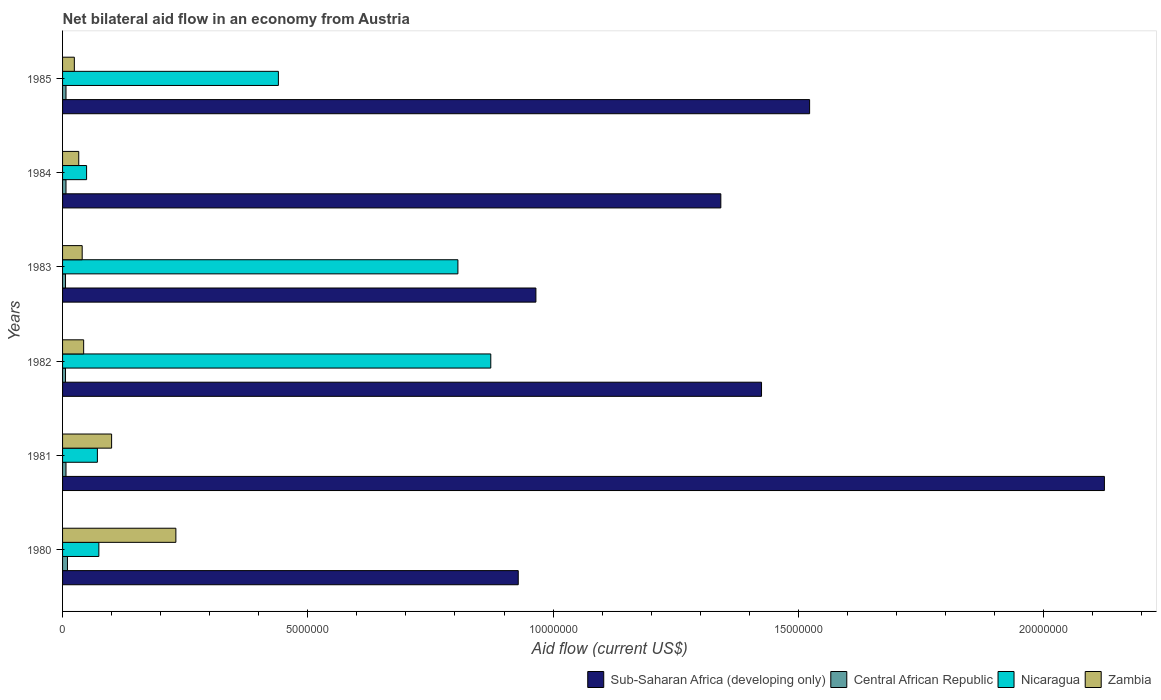How many groups of bars are there?
Provide a short and direct response. 6. Are the number of bars per tick equal to the number of legend labels?
Your response must be concise. Yes. Are the number of bars on each tick of the Y-axis equal?
Your answer should be very brief. Yes. How many bars are there on the 2nd tick from the bottom?
Provide a short and direct response. 4. What is the label of the 5th group of bars from the top?
Offer a very short reply. 1981. What is the net bilateral aid flow in Zambia in 1983?
Offer a terse response. 4.00e+05. Across all years, what is the maximum net bilateral aid flow in Nicaragua?
Ensure brevity in your answer.  8.73e+06. Across all years, what is the minimum net bilateral aid flow in Sub-Saharan Africa (developing only)?
Your answer should be very brief. 9.29e+06. In which year was the net bilateral aid flow in Sub-Saharan Africa (developing only) maximum?
Keep it short and to the point. 1981. In which year was the net bilateral aid flow in Central African Republic minimum?
Your response must be concise. 1982. What is the total net bilateral aid flow in Sub-Saharan Africa (developing only) in the graph?
Your response must be concise. 8.31e+07. What is the difference between the net bilateral aid flow in Nicaragua in 1980 and that in 1985?
Your answer should be very brief. -3.66e+06. What is the average net bilateral aid flow in Nicaragua per year?
Give a very brief answer. 3.86e+06. In the year 1981, what is the difference between the net bilateral aid flow in Zambia and net bilateral aid flow in Sub-Saharan Africa (developing only)?
Ensure brevity in your answer.  -2.02e+07. What is the ratio of the net bilateral aid flow in Sub-Saharan Africa (developing only) in 1980 to that in 1983?
Ensure brevity in your answer.  0.96. Is the difference between the net bilateral aid flow in Zambia in 1981 and 1985 greater than the difference between the net bilateral aid flow in Sub-Saharan Africa (developing only) in 1981 and 1985?
Provide a succinct answer. No. What is the difference between the highest and the second highest net bilateral aid flow in Zambia?
Provide a succinct answer. 1.31e+06. What is the difference between the highest and the lowest net bilateral aid flow in Nicaragua?
Keep it short and to the point. 8.24e+06. In how many years, is the net bilateral aid flow in Sub-Saharan Africa (developing only) greater than the average net bilateral aid flow in Sub-Saharan Africa (developing only) taken over all years?
Offer a very short reply. 3. Is the sum of the net bilateral aid flow in Sub-Saharan Africa (developing only) in 1981 and 1984 greater than the maximum net bilateral aid flow in Central African Republic across all years?
Your response must be concise. Yes. Is it the case that in every year, the sum of the net bilateral aid flow in Zambia and net bilateral aid flow in Nicaragua is greater than the sum of net bilateral aid flow in Sub-Saharan Africa (developing only) and net bilateral aid flow in Central African Republic?
Offer a terse response. No. What does the 4th bar from the top in 1983 represents?
Offer a terse response. Sub-Saharan Africa (developing only). What does the 2nd bar from the bottom in 1980 represents?
Keep it short and to the point. Central African Republic. Are all the bars in the graph horizontal?
Your answer should be compact. Yes. How many years are there in the graph?
Your answer should be compact. 6. Does the graph contain any zero values?
Your answer should be compact. No. Does the graph contain grids?
Offer a terse response. No. How many legend labels are there?
Your answer should be very brief. 4. How are the legend labels stacked?
Give a very brief answer. Horizontal. What is the title of the graph?
Provide a short and direct response. Net bilateral aid flow in an economy from Austria. Does "Equatorial Guinea" appear as one of the legend labels in the graph?
Your response must be concise. No. What is the label or title of the X-axis?
Your answer should be very brief. Aid flow (current US$). What is the Aid flow (current US$) in Sub-Saharan Africa (developing only) in 1980?
Give a very brief answer. 9.29e+06. What is the Aid flow (current US$) of Nicaragua in 1980?
Ensure brevity in your answer.  7.40e+05. What is the Aid flow (current US$) in Zambia in 1980?
Offer a very short reply. 2.31e+06. What is the Aid flow (current US$) of Sub-Saharan Africa (developing only) in 1981?
Your answer should be compact. 2.12e+07. What is the Aid flow (current US$) in Central African Republic in 1981?
Make the answer very short. 7.00e+04. What is the Aid flow (current US$) in Nicaragua in 1981?
Offer a very short reply. 7.10e+05. What is the Aid flow (current US$) in Sub-Saharan Africa (developing only) in 1982?
Provide a succinct answer. 1.42e+07. What is the Aid flow (current US$) of Central African Republic in 1982?
Provide a succinct answer. 6.00e+04. What is the Aid flow (current US$) of Nicaragua in 1982?
Keep it short and to the point. 8.73e+06. What is the Aid flow (current US$) in Zambia in 1982?
Ensure brevity in your answer.  4.30e+05. What is the Aid flow (current US$) of Sub-Saharan Africa (developing only) in 1983?
Provide a succinct answer. 9.65e+06. What is the Aid flow (current US$) of Central African Republic in 1983?
Your response must be concise. 6.00e+04. What is the Aid flow (current US$) in Nicaragua in 1983?
Offer a terse response. 8.06e+06. What is the Aid flow (current US$) in Zambia in 1983?
Give a very brief answer. 4.00e+05. What is the Aid flow (current US$) of Sub-Saharan Africa (developing only) in 1984?
Keep it short and to the point. 1.34e+07. What is the Aid flow (current US$) in Central African Republic in 1984?
Provide a succinct answer. 7.00e+04. What is the Aid flow (current US$) in Nicaragua in 1984?
Offer a very short reply. 4.90e+05. What is the Aid flow (current US$) of Zambia in 1984?
Provide a succinct answer. 3.30e+05. What is the Aid flow (current US$) in Sub-Saharan Africa (developing only) in 1985?
Your response must be concise. 1.52e+07. What is the Aid flow (current US$) of Nicaragua in 1985?
Provide a succinct answer. 4.40e+06. What is the Aid flow (current US$) of Zambia in 1985?
Give a very brief answer. 2.40e+05. Across all years, what is the maximum Aid flow (current US$) in Sub-Saharan Africa (developing only)?
Provide a short and direct response. 2.12e+07. Across all years, what is the maximum Aid flow (current US$) of Central African Republic?
Offer a terse response. 1.00e+05. Across all years, what is the maximum Aid flow (current US$) of Nicaragua?
Your answer should be very brief. 8.73e+06. Across all years, what is the maximum Aid flow (current US$) in Zambia?
Your answer should be very brief. 2.31e+06. Across all years, what is the minimum Aid flow (current US$) in Sub-Saharan Africa (developing only)?
Provide a succinct answer. 9.29e+06. Across all years, what is the minimum Aid flow (current US$) of Zambia?
Your answer should be very brief. 2.40e+05. What is the total Aid flow (current US$) of Sub-Saharan Africa (developing only) in the graph?
Your response must be concise. 8.31e+07. What is the total Aid flow (current US$) in Nicaragua in the graph?
Provide a short and direct response. 2.31e+07. What is the total Aid flow (current US$) in Zambia in the graph?
Make the answer very short. 4.71e+06. What is the difference between the Aid flow (current US$) in Sub-Saharan Africa (developing only) in 1980 and that in 1981?
Keep it short and to the point. -1.20e+07. What is the difference between the Aid flow (current US$) of Central African Republic in 1980 and that in 1981?
Offer a very short reply. 3.00e+04. What is the difference between the Aid flow (current US$) of Zambia in 1980 and that in 1981?
Offer a very short reply. 1.31e+06. What is the difference between the Aid flow (current US$) of Sub-Saharan Africa (developing only) in 1980 and that in 1982?
Offer a terse response. -4.96e+06. What is the difference between the Aid flow (current US$) of Central African Republic in 1980 and that in 1982?
Ensure brevity in your answer.  4.00e+04. What is the difference between the Aid flow (current US$) of Nicaragua in 1980 and that in 1982?
Keep it short and to the point. -7.99e+06. What is the difference between the Aid flow (current US$) of Zambia in 1980 and that in 1982?
Provide a succinct answer. 1.88e+06. What is the difference between the Aid flow (current US$) in Sub-Saharan Africa (developing only) in 1980 and that in 1983?
Keep it short and to the point. -3.60e+05. What is the difference between the Aid flow (current US$) in Nicaragua in 1980 and that in 1983?
Keep it short and to the point. -7.32e+06. What is the difference between the Aid flow (current US$) in Zambia in 1980 and that in 1983?
Keep it short and to the point. 1.91e+06. What is the difference between the Aid flow (current US$) in Sub-Saharan Africa (developing only) in 1980 and that in 1984?
Provide a short and direct response. -4.13e+06. What is the difference between the Aid flow (current US$) in Central African Republic in 1980 and that in 1984?
Your response must be concise. 3.00e+04. What is the difference between the Aid flow (current US$) in Nicaragua in 1980 and that in 1984?
Your answer should be very brief. 2.50e+05. What is the difference between the Aid flow (current US$) of Zambia in 1980 and that in 1984?
Your answer should be compact. 1.98e+06. What is the difference between the Aid flow (current US$) in Sub-Saharan Africa (developing only) in 1980 and that in 1985?
Your answer should be very brief. -5.94e+06. What is the difference between the Aid flow (current US$) in Nicaragua in 1980 and that in 1985?
Make the answer very short. -3.66e+06. What is the difference between the Aid flow (current US$) of Zambia in 1980 and that in 1985?
Your answer should be very brief. 2.07e+06. What is the difference between the Aid flow (current US$) in Sub-Saharan Africa (developing only) in 1981 and that in 1982?
Your answer should be compact. 6.99e+06. What is the difference between the Aid flow (current US$) in Nicaragua in 1981 and that in 1982?
Ensure brevity in your answer.  -8.02e+06. What is the difference between the Aid flow (current US$) of Zambia in 1981 and that in 1982?
Your response must be concise. 5.70e+05. What is the difference between the Aid flow (current US$) of Sub-Saharan Africa (developing only) in 1981 and that in 1983?
Your answer should be very brief. 1.16e+07. What is the difference between the Aid flow (current US$) of Nicaragua in 1981 and that in 1983?
Make the answer very short. -7.35e+06. What is the difference between the Aid flow (current US$) of Zambia in 1981 and that in 1983?
Keep it short and to the point. 6.00e+05. What is the difference between the Aid flow (current US$) of Sub-Saharan Africa (developing only) in 1981 and that in 1984?
Provide a succinct answer. 7.82e+06. What is the difference between the Aid flow (current US$) of Zambia in 1981 and that in 1984?
Provide a succinct answer. 6.70e+05. What is the difference between the Aid flow (current US$) in Sub-Saharan Africa (developing only) in 1981 and that in 1985?
Your answer should be compact. 6.01e+06. What is the difference between the Aid flow (current US$) in Central African Republic in 1981 and that in 1985?
Give a very brief answer. 0. What is the difference between the Aid flow (current US$) of Nicaragua in 1981 and that in 1985?
Ensure brevity in your answer.  -3.69e+06. What is the difference between the Aid flow (current US$) of Zambia in 1981 and that in 1985?
Give a very brief answer. 7.60e+05. What is the difference between the Aid flow (current US$) of Sub-Saharan Africa (developing only) in 1982 and that in 1983?
Your answer should be very brief. 4.60e+06. What is the difference between the Aid flow (current US$) of Nicaragua in 1982 and that in 1983?
Your answer should be compact. 6.70e+05. What is the difference between the Aid flow (current US$) of Sub-Saharan Africa (developing only) in 1982 and that in 1984?
Make the answer very short. 8.30e+05. What is the difference between the Aid flow (current US$) of Central African Republic in 1982 and that in 1984?
Keep it short and to the point. -10000. What is the difference between the Aid flow (current US$) of Nicaragua in 1982 and that in 1984?
Provide a short and direct response. 8.24e+06. What is the difference between the Aid flow (current US$) in Sub-Saharan Africa (developing only) in 1982 and that in 1985?
Your answer should be compact. -9.80e+05. What is the difference between the Aid flow (current US$) of Central African Republic in 1982 and that in 1985?
Offer a terse response. -10000. What is the difference between the Aid flow (current US$) in Nicaragua in 1982 and that in 1985?
Your response must be concise. 4.33e+06. What is the difference between the Aid flow (current US$) of Zambia in 1982 and that in 1985?
Offer a very short reply. 1.90e+05. What is the difference between the Aid flow (current US$) of Sub-Saharan Africa (developing only) in 1983 and that in 1984?
Your answer should be compact. -3.77e+06. What is the difference between the Aid flow (current US$) of Central African Republic in 1983 and that in 1984?
Offer a very short reply. -10000. What is the difference between the Aid flow (current US$) of Nicaragua in 1983 and that in 1984?
Provide a succinct answer. 7.57e+06. What is the difference between the Aid flow (current US$) in Zambia in 1983 and that in 1984?
Offer a terse response. 7.00e+04. What is the difference between the Aid flow (current US$) in Sub-Saharan Africa (developing only) in 1983 and that in 1985?
Offer a very short reply. -5.58e+06. What is the difference between the Aid flow (current US$) in Central African Republic in 1983 and that in 1985?
Offer a very short reply. -10000. What is the difference between the Aid flow (current US$) of Nicaragua in 1983 and that in 1985?
Provide a short and direct response. 3.66e+06. What is the difference between the Aid flow (current US$) of Sub-Saharan Africa (developing only) in 1984 and that in 1985?
Your answer should be compact. -1.81e+06. What is the difference between the Aid flow (current US$) in Nicaragua in 1984 and that in 1985?
Your answer should be compact. -3.91e+06. What is the difference between the Aid flow (current US$) of Sub-Saharan Africa (developing only) in 1980 and the Aid flow (current US$) of Central African Republic in 1981?
Keep it short and to the point. 9.22e+06. What is the difference between the Aid flow (current US$) in Sub-Saharan Africa (developing only) in 1980 and the Aid flow (current US$) in Nicaragua in 1981?
Your answer should be compact. 8.58e+06. What is the difference between the Aid flow (current US$) of Sub-Saharan Africa (developing only) in 1980 and the Aid flow (current US$) of Zambia in 1981?
Offer a terse response. 8.29e+06. What is the difference between the Aid flow (current US$) of Central African Republic in 1980 and the Aid flow (current US$) of Nicaragua in 1981?
Offer a terse response. -6.10e+05. What is the difference between the Aid flow (current US$) of Central African Republic in 1980 and the Aid flow (current US$) of Zambia in 1981?
Give a very brief answer. -9.00e+05. What is the difference between the Aid flow (current US$) of Nicaragua in 1980 and the Aid flow (current US$) of Zambia in 1981?
Ensure brevity in your answer.  -2.60e+05. What is the difference between the Aid flow (current US$) in Sub-Saharan Africa (developing only) in 1980 and the Aid flow (current US$) in Central African Republic in 1982?
Your answer should be very brief. 9.23e+06. What is the difference between the Aid flow (current US$) in Sub-Saharan Africa (developing only) in 1980 and the Aid flow (current US$) in Nicaragua in 1982?
Provide a short and direct response. 5.60e+05. What is the difference between the Aid flow (current US$) in Sub-Saharan Africa (developing only) in 1980 and the Aid flow (current US$) in Zambia in 1982?
Offer a very short reply. 8.86e+06. What is the difference between the Aid flow (current US$) in Central African Republic in 1980 and the Aid flow (current US$) in Nicaragua in 1982?
Offer a terse response. -8.63e+06. What is the difference between the Aid flow (current US$) of Central African Republic in 1980 and the Aid flow (current US$) of Zambia in 1982?
Your response must be concise. -3.30e+05. What is the difference between the Aid flow (current US$) of Nicaragua in 1980 and the Aid flow (current US$) of Zambia in 1982?
Offer a terse response. 3.10e+05. What is the difference between the Aid flow (current US$) of Sub-Saharan Africa (developing only) in 1980 and the Aid flow (current US$) of Central African Republic in 1983?
Keep it short and to the point. 9.23e+06. What is the difference between the Aid flow (current US$) in Sub-Saharan Africa (developing only) in 1980 and the Aid flow (current US$) in Nicaragua in 1983?
Your answer should be compact. 1.23e+06. What is the difference between the Aid flow (current US$) in Sub-Saharan Africa (developing only) in 1980 and the Aid flow (current US$) in Zambia in 1983?
Keep it short and to the point. 8.89e+06. What is the difference between the Aid flow (current US$) of Central African Republic in 1980 and the Aid flow (current US$) of Nicaragua in 1983?
Keep it short and to the point. -7.96e+06. What is the difference between the Aid flow (current US$) of Sub-Saharan Africa (developing only) in 1980 and the Aid flow (current US$) of Central African Republic in 1984?
Offer a very short reply. 9.22e+06. What is the difference between the Aid flow (current US$) of Sub-Saharan Africa (developing only) in 1980 and the Aid flow (current US$) of Nicaragua in 1984?
Keep it short and to the point. 8.80e+06. What is the difference between the Aid flow (current US$) of Sub-Saharan Africa (developing only) in 1980 and the Aid flow (current US$) of Zambia in 1984?
Offer a terse response. 8.96e+06. What is the difference between the Aid flow (current US$) of Central African Republic in 1980 and the Aid flow (current US$) of Nicaragua in 1984?
Your answer should be compact. -3.90e+05. What is the difference between the Aid flow (current US$) in Central African Republic in 1980 and the Aid flow (current US$) in Zambia in 1984?
Offer a very short reply. -2.30e+05. What is the difference between the Aid flow (current US$) in Sub-Saharan Africa (developing only) in 1980 and the Aid flow (current US$) in Central African Republic in 1985?
Provide a short and direct response. 9.22e+06. What is the difference between the Aid flow (current US$) in Sub-Saharan Africa (developing only) in 1980 and the Aid flow (current US$) in Nicaragua in 1985?
Offer a very short reply. 4.89e+06. What is the difference between the Aid flow (current US$) of Sub-Saharan Africa (developing only) in 1980 and the Aid flow (current US$) of Zambia in 1985?
Keep it short and to the point. 9.05e+06. What is the difference between the Aid flow (current US$) in Central African Republic in 1980 and the Aid flow (current US$) in Nicaragua in 1985?
Your answer should be very brief. -4.30e+06. What is the difference between the Aid flow (current US$) in Nicaragua in 1980 and the Aid flow (current US$) in Zambia in 1985?
Your answer should be compact. 5.00e+05. What is the difference between the Aid flow (current US$) of Sub-Saharan Africa (developing only) in 1981 and the Aid flow (current US$) of Central African Republic in 1982?
Make the answer very short. 2.12e+07. What is the difference between the Aid flow (current US$) in Sub-Saharan Africa (developing only) in 1981 and the Aid flow (current US$) in Nicaragua in 1982?
Your answer should be compact. 1.25e+07. What is the difference between the Aid flow (current US$) of Sub-Saharan Africa (developing only) in 1981 and the Aid flow (current US$) of Zambia in 1982?
Your response must be concise. 2.08e+07. What is the difference between the Aid flow (current US$) in Central African Republic in 1981 and the Aid flow (current US$) in Nicaragua in 1982?
Keep it short and to the point. -8.66e+06. What is the difference between the Aid flow (current US$) of Central African Republic in 1981 and the Aid flow (current US$) of Zambia in 1982?
Provide a succinct answer. -3.60e+05. What is the difference between the Aid flow (current US$) in Nicaragua in 1981 and the Aid flow (current US$) in Zambia in 1982?
Your answer should be very brief. 2.80e+05. What is the difference between the Aid flow (current US$) in Sub-Saharan Africa (developing only) in 1981 and the Aid flow (current US$) in Central African Republic in 1983?
Provide a short and direct response. 2.12e+07. What is the difference between the Aid flow (current US$) in Sub-Saharan Africa (developing only) in 1981 and the Aid flow (current US$) in Nicaragua in 1983?
Provide a succinct answer. 1.32e+07. What is the difference between the Aid flow (current US$) of Sub-Saharan Africa (developing only) in 1981 and the Aid flow (current US$) of Zambia in 1983?
Offer a very short reply. 2.08e+07. What is the difference between the Aid flow (current US$) in Central African Republic in 1981 and the Aid flow (current US$) in Nicaragua in 1983?
Offer a very short reply. -7.99e+06. What is the difference between the Aid flow (current US$) of Central African Republic in 1981 and the Aid flow (current US$) of Zambia in 1983?
Offer a very short reply. -3.30e+05. What is the difference between the Aid flow (current US$) of Sub-Saharan Africa (developing only) in 1981 and the Aid flow (current US$) of Central African Republic in 1984?
Provide a short and direct response. 2.12e+07. What is the difference between the Aid flow (current US$) of Sub-Saharan Africa (developing only) in 1981 and the Aid flow (current US$) of Nicaragua in 1984?
Keep it short and to the point. 2.08e+07. What is the difference between the Aid flow (current US$) in Sub-Saharan Africa (developing only) in 1981 and the Aid flow (current US$) in Zambia in 1984?
Keep it short and to the point. 2.09e+07. What is the difference between the Aid flow (current US$) in Central African Republic in 1981 and the Aid flow (current US$) in Nicaragua in 1984?
Provide a succinct answer. -4.20e+05. What is the difference between the Aid flow (current US$) of Sub-Saharan Africa (developing only) in 1981 and the Aid flow (current US$) of Central African Republic in 1985?
Your response must be concise. 2.12e+07. What is the difference between the Aid flow (current US$) in Sub-Saharan Africa (developing only) in 1981 and the Aid flow (current US$) in Nicaragua in 1985?
Make the answer very short. 1.68e+07. What is the difference between the Aid flow (current US$) of Sub-Saharan Africa (developing only) in 1981 and the Aid flow (current US$) of Zambia in 1985?
Your response must be concise. 2.10e+07. What is the difference between the Aid flow (current US$) in Central African Republic in 1981 and the Aid flow (current US$) in Nicaragua in 1985?
Provide a short and direct response. -4.33e+06. What is the difference between the Aid flow (current US$) of Central African Republic in 1981 and the Aid flow (current US$) of Zambia in 1985?
Give a very brief answer. -1.70e+05. What is the difference between the Aid flow (current US$) of Sub-Saharan Africa (developing only) in 1982 and the Aid flow (current US$) of Central African Republic in 1983?
Offer a terse response. 1.42e+07. What is the difference between the Aid flow (current US$) of Sub-Saharan Africa (developing only) in 1982 and the Aid flow (current US$) of Nicaragua in 1983?
Keep it short and to the point. 6.19e+06. What is the difference between the Aid flow (current US$) of Sub-Saharan Africa (developing only) in 1982 and the Aid flow (current US$) of Zambia in 1983?
Your response must be concise. 1.38e+07. What is the difference between the Aid flow (current US$) of Central African Republic in 1982 and the Aid flow (current US$) of Nicaragua in 1983?
Your response must be concise. -8.00e+06. What is the difference between the Aid flow (current US$) of Nicaragua in 1982 and the Aid flow (current US$) of Zambia in 1983?
Your answer should be very brief. 8.33e+06. What is the difference between the Aid flow (current US$) in Sub-Saharan Africa (developing only) in 1982 and the Aid flow (current US$) in Central African Republic in 1984?
Ensure brevity in your answer.  1.42e+07. What is the difference between the Aid flow (current US$) of Sub-Saharan Africa (developing only) in 1982 and the Aid flow (current US$) of Nicaragua in 1984?
Provide a succinct answer. 1.38e+07. What is the difference between the Aid flow (current US$) in Sub-Saharan Africa (developing only) in 1982 and the Aid flow (current US$) in Zambia in 1984?
Your answer should be compact. 1.39e+07. What is the difference between the Aid flow (current US$) in Central African Republic in 1982 and the Aid flow (current US$) in Nicaragua in 1984?
Keep it short and to the point. -4.30e+05. What is the difference between the Aid flow (current US$) in Nicaragua in 1982 and the Aid flow (current US$) in Zambia in 1984?
Offer a terse response. 8.40e+06. What is the difference between the Aid flow (current US$) of Sub-Saharan Africa (developing only) in 1982 and the Aid flow (current US$) of Central African Republic in 1985?
Offer a terse response. 1.42e+07. What is the difference between the Aid flow (current US$) of Sub-Saharan Africa (developing only) in 1982 and the Aid flow (current US$) of Nicaragua in 1985?
Provide a short and direct response. 9.85e+06. What is the difference between the Aid flow (current US$) in Sub-Saharan Africa (developing only) in 1982 and the Aid flow (current US$) in Zambia in 1985?
Your response must be concise. 1.40e+07. What is the difference between the Aid flow (current US$) of Central African Republic in 1982 and the Aid flow (current US$) of Nicaragua in 1985?
Keep it short and to the point. -4.34e+06. What is the difference between the Aid flow (current US$) in Nicaragua in 1982 and the Aid flow (current US$) in Zambia in 1985?
Provide a short and direct response. 8.49e+06. What is the difference between the Aid flow (current US$) of Sub-Saharan Africa (developing only) in 1983 and the Aid flow (current US$) of Central African Republic in 1984?
Make the answer very short. 9.58e+06. What is the difference between the Aid flow (current US$) of Sub-Saharan Africa (developing only) in 1983 and the Aid flow (current US$) of Nicaragua in 1984?
Your answer should be compact. 9.16e+06. What is the difference between the Aid flow (current US$) of Sub-Saharan Africa (developing only) in 1983 and the Aid flow (current US$) of Zambia in 1984?
Offer a terse response. 9.32e+06. What is the difference between the Aid flow (current US$) of Central African Republic in 1983 and the Aid flow (current US$) of Nicaragua in 1984?
Keep it short and to the point. -4.30e+05. What is the difference between the Aid flow (current US$) of Central African Republic in 1983 and the Aid flow (current US$) of Zambia in 1984?
Your answer should be very brief. -2.70e+05. What is the difference between the Aid flow (current US$) of Nicaragua in 1983 and the Aid flow (current US$) of Zambia in 1984?
Your answer should be very brief. 7.73e+06. What is the difference between the Aid flow (current US$) in Sub-Saharan Africa (developing only) in 1983 and the Aid flow (current US$) in Central African Republic in 1985?
Give a very brief answer. 9.58e+06. What is the difference between the Aid flow (current US$) in Sub-Saharan Africa (developing only) in 1983 and the Aid flow (current US$) in Nicaragua in 1985?
Offer a terse response. 5.25e+06. What is the difference between the Aid flow (current US$) in Sub-Saharan Africa (developing only) in 1983 and the Aid flow (current US$) in Zambia in 1985?
Your answer should be compact. 9.41e+06. What is the difference between the Aid flow (current US$) in Central African Republic in 1983 and the Aid flow (current US$) in Nicaragua in 1985?
Ensure brevity in your answer.  -4.34e+06. What is the difference between the Aid flow (current US$) of Nicaragua in 1983 and the Aid flow (current US$) of Zambia in 1985?
Your answer should be compact. 7.82e+06. What is the difference between the Aid flow (current US$) of Sub-Saharan Africa (developing only) in 1984 and the Aid flow (current US$) of Central African Republic in 1985?
Ensure brevity in your answer.  1.34e+07. What is the difference between the Aid flow (current US$) of Sub-Saharan Africa (developing only) in 1984 and the Aid flow (current US$) of Nicaragua in 1985?
Offer a terse response. 9.02e+06. What is the difference between the Aid flow (current US$) in Sub-Saharan Africa (developing only) in 1984 and the Aid flow (current US$) in Zambia in 1985?
Provide a short and direct response. 1.32e+07. What is the difference between the Aid flow (current US$) of Central African Republic in 1984 and the Aid flow (current US$) of Nicaragua in 1985?
Your answer should be compact. -4.33e+06. What is the average Aid flow (current US$) of Sub-Saharan Africa (developing only) per year?
Offer a terse response. 1.38e+07. What is the average Aid flow (current US$) in Central African Republic per year?
Give a very brief answer. 7.17e+04. What is the average Aid flow (current US$) of Nicaragua per year?
Your response must be concise. 3.86e+06. What is the average Aid flow (current US$) of Zambia per year?
Keep it short and to the point. 7.85e+05. In the year 1980, what is the difference between the Aid flow (current US$) in Sub-Saharan Africa (developing only) and Aid flow (current US$) in Central African Republic?
Ensure brevity in your answer.  9.19e+06. In the year 1980, what is the difference between the Aid flow (current US$) of Sub-Saharan Africa (developing only) and Aid flow (current US$) of Nicaragua?
Offer a very short reply. 8.55e+06. In the year 1980, what is the difference between the Aid flow (current US$) in Sub-Saharan Africa (developing only) and Aid flow (current US$) in Zambia?
Your answer should be very brief. 6.98e+06. In the year 1980, what is the difference between the Aid flow (current US$) of Central African Republic and Aid flow (current US$) of Nicaragua?
Make the answer very short. -6.40e+05. In the year 1980, what is the difference between the Aid flow (current US$) in Central African Republic and Aid flow (current US$) in Zambia?
Provide a succinct answer. -2.21e+06. In the year 1980, what is the difference between the Aid flow (current US$) of Nicaragua and Aid flow (current US$) of Zambia?
Give a very brief answer. -1.57e+06. In the year 1981, what is the difference between the Aid flow (current US$) in Sub-Saharan Africa (developing only) and Aid flow (current US$) in Central African Republic?
Provide a succinct answer. 2.12e+07. In the year 1981, what is the difference between the Aid flow (current US$) of Sub-Saharan Africa (developing only) and Aid flow (current US$) of Nicaragua?
Offer a terse response. 2.05e+07. In the year 1981, what is the difference between the Aid flow (current US$) of Sub-Saharan Africa (developing only) and Aid flow (current US$) of Zambia?
Your answer should be compact. 2.02e+07. In the year 1981, what is the difference between the Aid flow (current US$) in Central African Republic and Aid flow (current US$) in Nicaragua?
Your response must be concise. -6.40e+05. In the year 1981, what is the difference between the Aid flow (current US$) in Central African Republic and Aid flow (current US$) in Zambia?
Keep it short and to the point. -9.30e+05. In the year 1982, what is the difference between the Aid flow (current US$) in Sub-Saharan Africa (developing only) and Aid flow (current US$) in Central African Republic?
Make the answer very short. 1.42e+07. In the year 1982, what is the difference between the Aid flow (current US$) of Sub-Saharan Africa (developing only) and Aid flow (current US$) of Nicaragua?
Keep it short and to the point. 5.52e+06. In the year 1982, what is the difference between the Aid flow (current US$) in Sub-Saharan Africa (developing only) and Aid flow (current US$) in Zambia?
Make the answer very short. 1.38e+07. In the year 1982, what is the difference between the Aid flow (current US$) of Central African Republic and Aid flow (current US$) of Nicaragua?
Keep it short and to the point. -8.67e+06. In the year 1982, what is the difference between the Aid flow (current US$) of Central African Republic and Aid flow (current US$) of Zambia?
Your response must be concise. -3.70e+05. In the year 1982, what is the difference between the Aid flow (current US$) in Nicaragua and Aid flow (current US$) in Zambia?
Your response must be concise. 8.30e+06. In the year 1983, what is the difference between the Aid flow (current US$) in Sub-Saharan Africa (developing only) and Aid flow (current US$) in Central African Republic?
Give a very brief answer. 9.59e+06. In the year 1983, what is the difference between the Aid flow (current US$) of Sub-Saharan Africa (developing only) and Aid flow (current US$) of Nicaragua?
Your answer should be very brief. 1.59e+06. In the year 1983, what is the difference between the Aid flow (current US$) in Sub-Saharan Africa (developing only) and Aid flow (current US$) in Zambia?
Keep it short and to the point. 9.25e+06. In the year 1983, what is the difference between the Aid flow (current US$) in Central African Republic and Aid flow (current US$) in Nicaragua?
Keep it short and to the point. -8.00e+06. In the year 1983, what is the difference between the Aid flow (current US$) in Central African Republic and Aid flow (current US$) in Zambia?
Ensure brevity in your answer.  -3.40e+05. In the year 1983, what is the difference between the Aid flow (current US$) in Nicaragua and Aid flow (current US$) in Zambia?
Your response must be concise. 7.66e+06. In the year 1984, what is the difference between the Aid flow (current US$) in Sub-Saharan Africa (developing only) and Aid flow (current US$) in Central African Republic?
Provide a succinct answer. 1.34e+07. In the year 1984, what is the difference between the Aid flow (current US$) in Sub-Saharan Africa (developing only) and Aid flow (current US$) in Nicaragua?
Keep it short and to the point. 1.29e+07. In the year 1984, what is the difference between the Aid flow (current US$) in Sub-Saharan Africa (developing only) and Aid flow (current US$) in Zambia?
Give a very brief answer. 1.31e+07. In the year 1984, what is the difference between the Aid flow (current US$) in Central African Republic and Aid flow (current US$) in Nicaragua?
Give a very brief answer. -4.20e+05. In the year 1984, what is the difference between the Aid flow (current US$) in Central African Republic and Aid flow (current US$) in Zambia?
Make the answer very short. -2.60e+05. In the year 1985, what is the difference between the Aid flow (current US$) of Sub-Saharan Africa (developing only) and Aid flow (current US$) of Central African Republic?
Provide a short and direct response. 1.52e+07. In the year 1985, what is the difference between the Aid flow (current US$) in Sub-Saharan Africa (developing only) and Aid flow (current US$) in Nicaragua?
Your answer should be very brief. 1.08e+07. In the year 1985, what is the difference between the Aid flow (current US$) of Sub-Saharan Africa (developing only) and Aid flow (current US$) of Zambia?
Offer a very short reply. 1.50e+07. In the year 1985, what is the difference between the Aid flow (current US$) of Central African Republic and Aid flow (current US$) of Nicaragua?
Give a very brief answer. -4.33e+06. In the year 1985, what is the difference between the Aid flow (current US$) in Central African Republic and Aid flow (current US$) in Zambia?
Your answer should be compact. -1.70e+05. In the year 1985, what is the difference between the Aid flow (current US$) of Nicaragua and Aid flow (current US$) of Zambia?
Offer a terse response. 4.16e+06. What is the ratio of the Aid flow (current US$) of Sub-Saharan Africa (developing only) in 1980 to that in 1981?
Offer a terse response. 0.44. What is the ratio of the Aid flow (current US$) of Central African Republic in 1980 to that in 1981?
Your answer should be very brief. 1.43. What is the ratio of the Aid flow (current US$) of Nicaragua in 1980 to that in 1981?
Give a very brief answer. 1.04. What is the ratio of the Aid flow (current US$) in Zambia in 1980 to that in 1981?
Offer a very short reply. 2.31. What is the ratio of the Aid flow (current US$) in Sub-Saharan Africa (developing only) in 1980 to that in 1982?
Offer a very short reply. 0.65. What is the ratio of the Aid flow (current US$) of Nicaragua in 1980 to that in 1982?
Your answer should be compact. 0.08. What is the ratio of the Aid flow (current US$) of Zambia in 1980 to that in 1982?
Your answer should be compact. 5.37. What is the ratio of the Aid flow (current US$) of Sub-Saharan Africa (developing only) in 1980 to that in 1983?
Offer a terse response. 0.96. What is the ratio of the Aid flow (current US$) in Nicaragua in 1980 to that in 1983?
Offer a terse response. 0.09. What is the ratio of the Aid flow (current US$) of Zambia in 1980 to that in 1983?
Provide a short and direct response. 5.78. What is the ratio of the Aid flow (current US$) of Sub-Saharan Africa (developing only) in 1980 to that in 1984?
Your answer should be very brief. 0.69. What is the ratio of the Aid flow (current US$) of Central African Republic in 1980 to that in 1984?
Offer a terse response. 1.43. What is the ratio of the Aid flow (current US$) of Nicaragua in 1980 to that in 1984?
Make the answer very short. 1.51. What is the ratio of the Aid flow (current US$) of Zambia in 1980 to that in 1984?
Make the answer very short. 7. What is the ratio of the Aid flow (current US$) of Sub-Saharan Africa (developing only) in 1980 to that in 1985?
Provide a succinct answer. 0.61. What is the ratio of the Aid flow (current US$) in Central African Republic in 1980 to that in 1985?
Provide a short and direct response. 1.43. What is the ratio of the Aid flow (current US$) in Nicaragua in 1980 to that in 1985?
Make the answer very short. 0.17. What is the ratio of the Aid flow (current US$) in Zambia in 1980 to that in 1985?
Your answer should be compact. 9.62. What is the ratio of the Aid flow (current US$) of Sub-Saharan Africa (developing only) in 1981 to that in 1982?
Make the answer very short. 1.49. What is the ratio of the Aid flow (current US$) in Nicaragua in 1981 to that in 1982?
Give a very brief answer. 0.08. What is the ratio of the Aid flow (current US$) in Zambia in 1981 to that in 1982?
Your response must be concise. 2.33. What is the ratio of the Aid flow (current US$) of Sub-Saharan Africa (developing only) in 1981 to that in 1983?
Make the answer very short. 2.2. What is the ratio of the Aid flow (current US$) in Nicaragua in 1981 to that in 1983?
Keep it short and to the point. 0.09. What is the ratio of the Aid flow (current US$) of Sub-Saharan Africa (developing only) in 1981 to that in 1984?
Offer a very short reply. 1.58. What is the ratio of the Aid flow (current US$) in Nicaragua in 1981 to that in 1984?
Offer a very short reply. 1.45. What is the ratio of the Aid flow (current US$) of Zambia in 1981 to that in 1984?
Offer a very short reply. 3.03. What is the ratio of the Aid flow (current US$) of Sub-Saharan Africa (developing only) in 1981 to that in 1985?
Provide a short and direct response. 1.39. What is the ratio of the Aid flow (current US$) in Central African Republic in 1981 to that in 1985?
Keep it short and to the point. 1. What is the ratio of the Aid flow (current US$) in Nicaragua in 1981 to that in 1985?
Provide a succinct answer. 0.16. What is the ratio of the Aid flow (current US$) in Zambia in 1981 to that in 1985?
Provide a short and direct response. 4.17. What is the ratio of the Aid flow (current US$) in Sub-Saharan Africa (developing only) in 1982 to that in 1983?
Make the answer very short. 1.48. What is the ratio of the Aid flow (current US$) of Nicaragua in 1982 to that in 1983?
Provide a succinct answer. 1.08. What is the ratio of the Aid flow (current US$) in Zambia in 1982 to that in 1983?
Ensure brevity in your answer.  1.07. What is the ratio of the Aid flow (current US$) of Sub-Saharan Africa (developing only) in 1982 to that in 1984?
Give a very brief answer. 1.06. What is the ratio of the Aid flow (current US$) of Nicaragua in 1982 to that in 1984?
Your response must be concise. 17.82. What is the ratio of the Aid flow (current US$) of Zambia in 1982 to that in 1984?
Make the answer very short. 1.3. What is the ratio of the Aid flow (current US$) of Sub-Saharan Africa (developing only) in 1982 to that in 1985?
Offer a very short reply. 0.94. What is the ratio of the Aid flow (current US$) of Nicaragua in 1982 to that in 1985?
Your answer should be compact. 1.98. What is the ratio of the Aid flow (current US$) in Zambia in 1982 to that in 1985?
Your answer should be very brief. 1.79. What is the ratio of the Aid flow (current US$) of Sub-Saharan Africa (developing only) in 1983 to that in 1984?
Give a very brief answer. 0.72. What is the ratio of the Aid flow (current US$) of Central African Republic in 1983 to that in 1984?
Offer a very short reply. 0.86. What is the ratio of the Aid flow (current US$) of Nicaragua in 1983 to that in 1984?
Ensure brevity in your answer.  16.45. What is the ratio of the Aid flow (current US$) of Zambia in 1983 to that in 1984?
Keep it short and to the point. 1.21. What is the ratio of the Aid flow (current US$) of Sub-Saharan Africa (developing only) in 1983 to that in 1985?
Offer a very short reply. 0.63. What is the ratio of the Aid flow (current US$) in Central African Republic in 1983 to that in 1985?
Provide a succinct answer. 0.86. What is the ratio of the Aid flow (current US$) of Nicaragua in 1983 to that in 1985?
Provide a succinct answer. 1.83. What is the ratio of the Aid flow (current US$) of Zambia in 1983 to that in 1985?
Provide a short and direct response. 1.67. What is the ratio of the Aid flow (current US$) of Sub-Saharan Africa (developing only) in 1984 to that in 1985?
Provide a succinct answer. 0.88. What is the ratio of the Aid flow (current US$) in Nicaragua in 1984 to that in 1985?
Make the answer very short. 0.11. What is the ratio of the Aid flow (current US$) of Zambia in 1984 to that in 1985?
Offer a terse response. 1.38. What is the difference between the highest and the second highest Aid flow (current US$) of Sub-Saharan Africa (developing only)?
Your answer should be compact. 6.01e+06. What is the difference between the highest and the second highest Aid flow (current US$) of Nicaragua?
Offer a terse response. 6.70e+05. What is the difference between the highest and the second highest Aid flow (current US$) in Zambia?
Make the answer very short. 1.31e+06. What is the difference between the highest and the lowest Aid flow (current US$) in Sub-Saharan Africa (developing only)?
Your response must be concise. 1.20e+07. What is the difference between the highest and the lowest Aid flow (current US$) in Nicaragua?
Offer a very short reply. 8.24e+06. What is the difference between the highest and the lowest Aid flow (current US$) in Zambia?
Your answer should be very brief. 2.07e+06. 